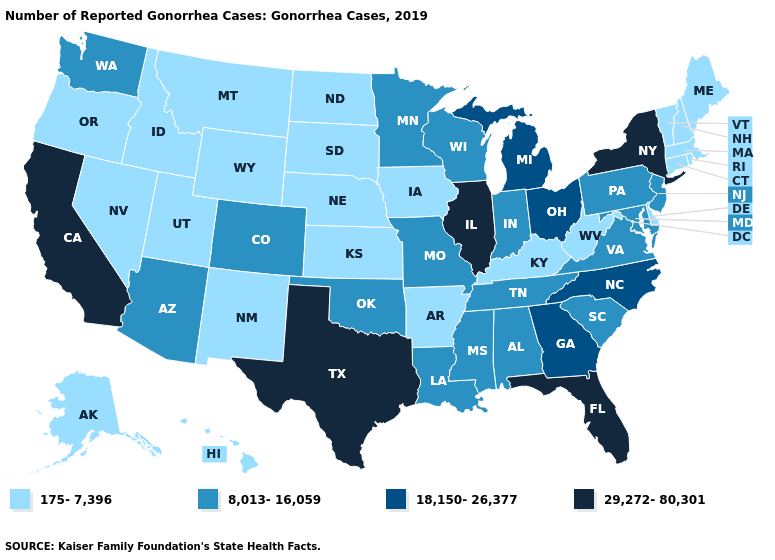Does Alabama have the lowest value in the USA?
Be succinct. No. What is the value of California?
Concise answer only. 29,272-80,301. Does the first symbol in the legend represent the smallest category?
Keep it brief. Yes. Is the legend a continuous bar?
Be succinct. No. What is the highest value in states that border Oklahoma?
Keep it brief. 29,272-80,301. Name the states that have a value in the range 8,013-16,059?
Concise answer only. Alabama, Arizona, Colorado, Indiana, Louisiana, Maryland, Minnesota, Mississippi, Missouri, New Jersey, Oklahoma, Pennsylvania, South Carolina, Tennessee, Virginia, Washington, Wisconsin. Name the states that have a value in the range 8,013-16,059?
Give a very brief answer. Alabama, Arizona, Colorado, Indiana, Louisiana, Maryland, Minnesota, Mississippi, Missouri, New Jersey, Oklahoma, Pennsylvania, South Carolina, Tennessee, Virginia, Washington, Wisconsin. Name the states that have a value in the range 8,013-16,059?
Concise answer only. Alabama, Arizona, Colorado, Indiana, Louisiana, Maryland, Minnesota, Mississippi, Missouri, New Jersey, Oklahoma, Pennsylvania, South Carolina, Tennessee, Virginia, Washington, Wisconsin. Does Maine have the highest value in the USA?
Quick response, please. No. What is the value of North Dakota?
Short answer required. 175-7,396. What is the value of Iowa?
Be succinct. 175-7,396. What is the highest value in the West ?
Short answer required. 29,272-80,301. Which states have the lowest value in the USA?
Write a very short answer. Alaska, Arkansas, Connecticut, Delaware, Hawaii, Idaho, Iowa, Kansas, Kentucky, Maine, Massachusetts, Montana, Nebraska, Nevada, New Hampshire, New Mexico, North Dakota, Oregon, Rhode Island, South Dakota, Utah, Vermont, West Virginia, Wyoming. Name the states that have a value in the range 175-7,396?
Be succinct. Alaska, Arkansas, Connecticut, Delaware, Hawaii, Idaho, Iowa, Kansas, Kentucky, Maine, Massachusetts, Montana, Nebraska, Nevada, New Hampshire, New Mexico, North Dakota, Oregon, Rhode Island, South Dakota, Utah, Vermont, West Virginia, Wyoming. What is the value of Arizona?
Write a very short answer. 8,013-16,059. 